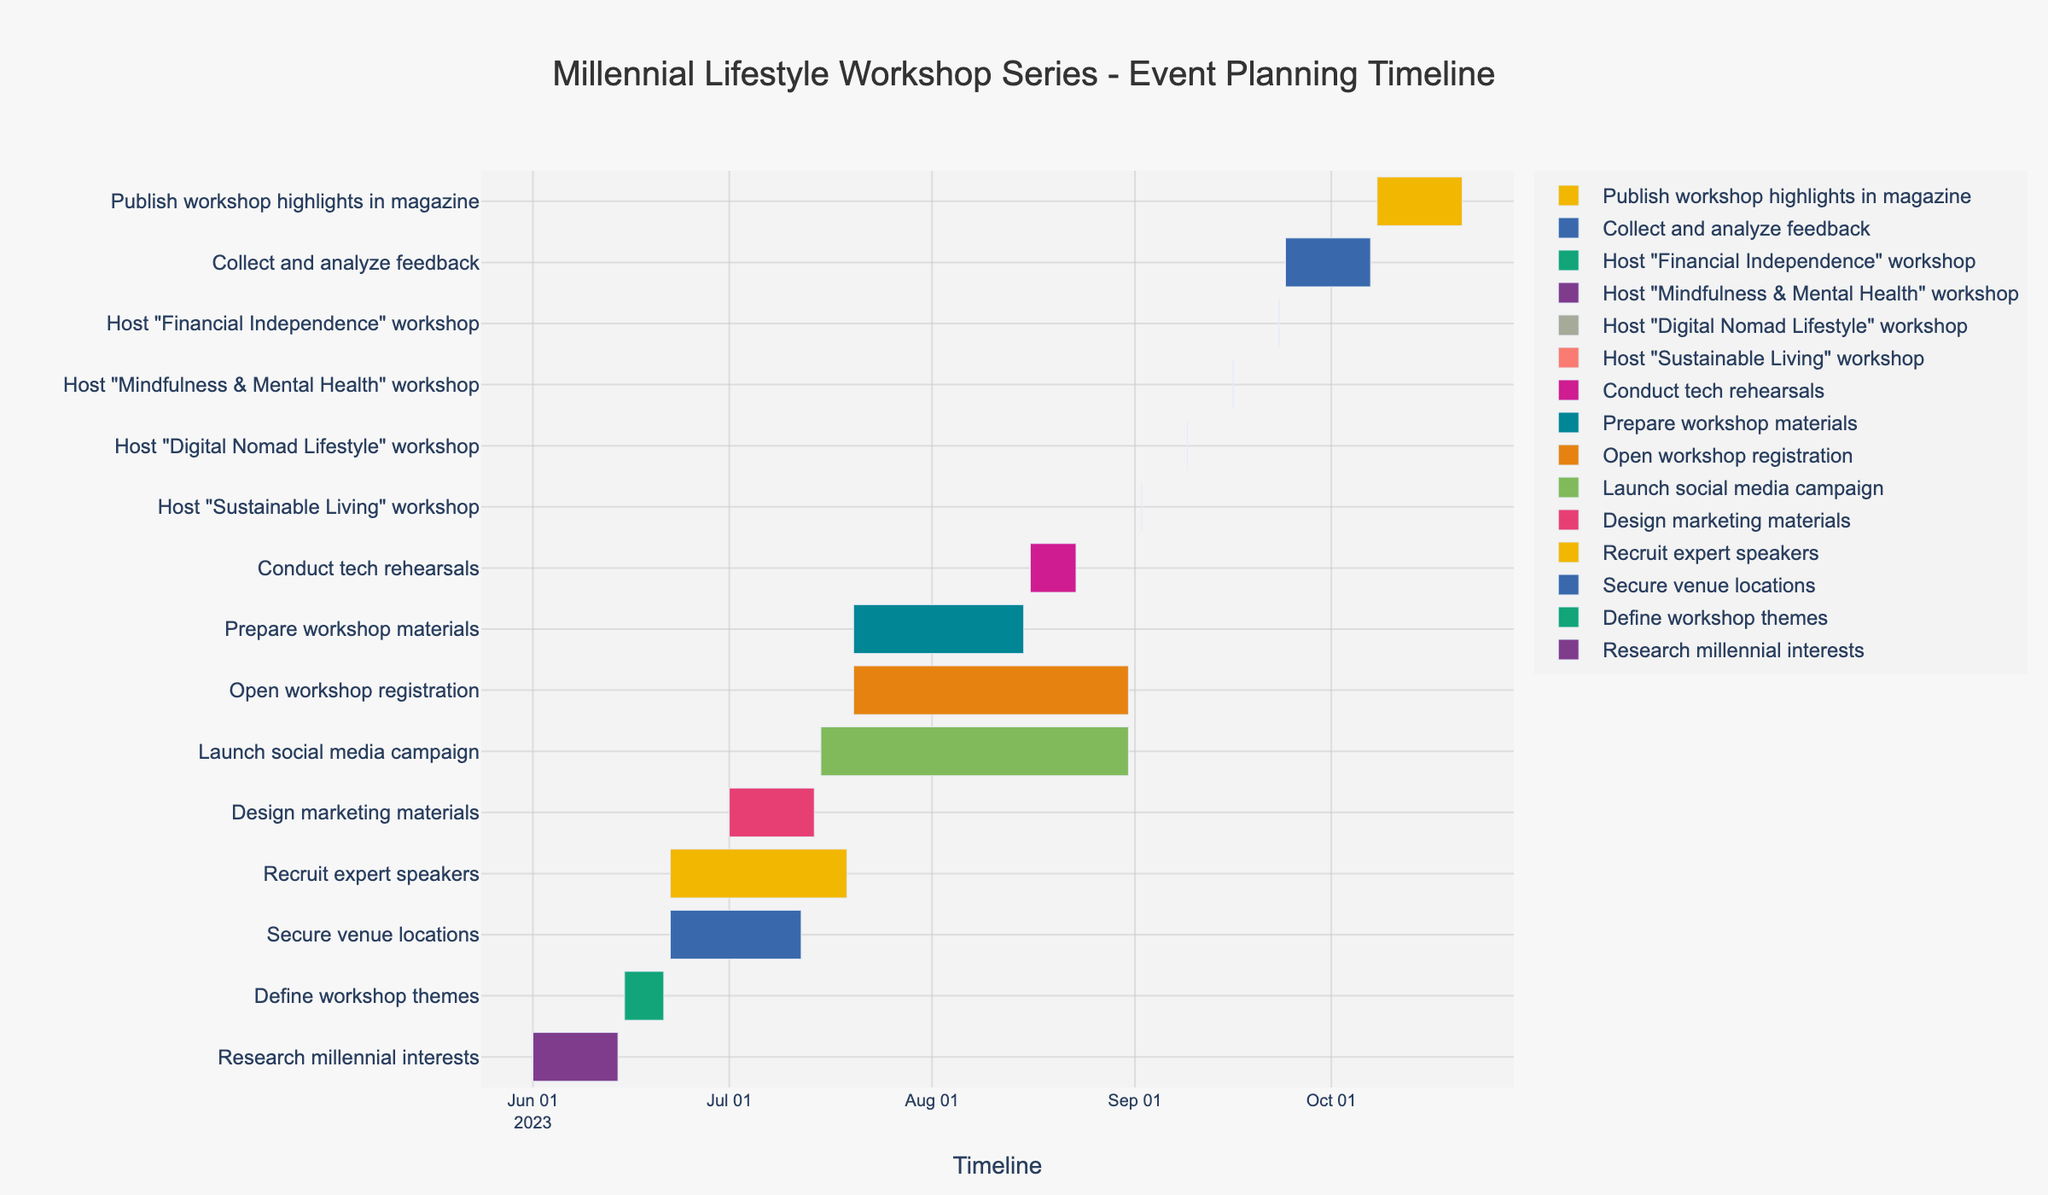Which task starts the earliest? The figure shows that "Research millennial interests" is the first task on the timeline, starting on June 1, 2023.
Answer: Research millennial interests Which task finishes the latest? The figure indicates that "Publish workshop highlights in magazine" is the last task on the timeline, ending on October 21, 2023.
Answer: Publish workshop highlights in magazine How long is the "Recruit expert speakers" task? To find the duration of the task, subtract the start date (June 22, 2023) from the end date (July 19, 2023). The result is 27 days.
Answer: 27 days What is the duration of time between when "Design marketing materials" ends and "Open workshop registration" starts? "Design marketing materials" ends on July 14, 2023, and "Open workshop registration" starts on July 20, 2023. Subtracting these dates gives a gap of 6 days.
Answer: 6 days Which tasks are ongoing simultaneously with "Design marketing materials"? According to the figure, "Secure venue locations," "Recruit expert speakers," and "Launch social media campaign" all overlap in timeline with "Design marketing materials" from July 1 to July 14, 2023.
Answer: Secure venue locations, Recruit expert speakers, Launch social media campaign Which workshop is hosted first and when? The Gantt chart shows that the "Sustainable Living" workshop is hosted first on September 2, 2023.
Answer: Sustainable Living, September 2, 2023 How many tasks are scheduled to occur in August? By examining the timeline in August, the tasks "Launch social media campaign," "Open workshop registration," "Prepare workshop materials," and "Conduct tech rehearsals" are scheduled during this month. Counting these, there are 4 tasks.
Answer: 4 tasks Which task overlaps with both "Open workshop registration" and "Prepare workshop materials"? "Launch social media campaign" is the task that overlaps with both "Open workshop registration" and "Prepare workshop materials" as it runs from July 15, 2023, to August 31, 2023.
Answer: Launch social media campaign Between "Research millennial interests" and "Define workshop themes," which task is shorter, and by how many days? "Research millennial interests" runs from June 1 to June 14 (14 days), and "Define workshop themes" runs from June 15 to June 21 (7 days). The difference in duration is 14 - 7 = 7 days.
Answer: Define workshop themes, 7 days Which two tasks are scheduled to start on the same day? The Gantt chart shows that "Secure venue locations" and "Recruit expert speakers" both start on June 22, 2023.
Answer: Secure venue locations, Recruit expert speakers 